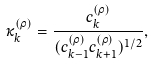<formula> <loc_0><loc_0><loc_500><loc_500>\kappa _ { k } ^ { ( \rho ) } = \frac { c _ { k } ^ { ( \rho ) } } { ( c _ { k - 1 } ^ { ( \rho ) } c _ { k + 1 } ^ { ( \rho ) } ) ^ { 1 / 2 } } ,</formula> 